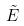<formula> <loc_0><loc_0><loc_500><loc_500>\tilde { E }</formula> 